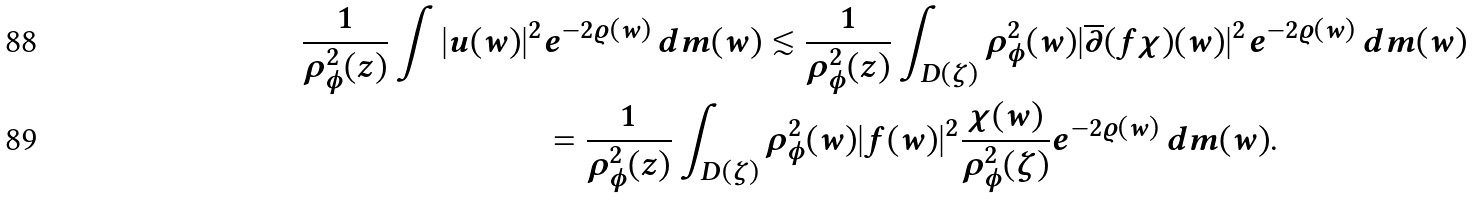<formula> <loc_0><loc_0><loc_500><loc_500>\frac { 1 } { \rho ^ { 2 } _ { \phi } ( z ) } \int | u ( w ) | ^ { 2 } & e ^ { - 2 \varrho ( w ) } \, d m ( w ) \lesssim \frac { 1 } { \rho ^ { 2 } _ { \phi } ( z ) } \int _ { D ( \zeta ) } \rho ^ { 2 } _ { \phi } ( w ) | \overline { \partial } ( f \chi ) ( w ) | ^ { 2 } e ^ { - 2 \varrho ( w ) } \, d m ( w ) \\ & = \frac { 1 } { \rho ^ { 2 } _ { \phi } ( z ) } \int _ { D ( \zeta ) } \rho ^ { 2 } _ { \phi } ( w ) | f ( w ) | ^ { 2 } \frac { \chi ( w ) } { \rho ^ { 2 } _ { \phi } ( \zeta ) } e ^ { - 2 \varrho ( w ) } \, d m ( w ) .</formula> 